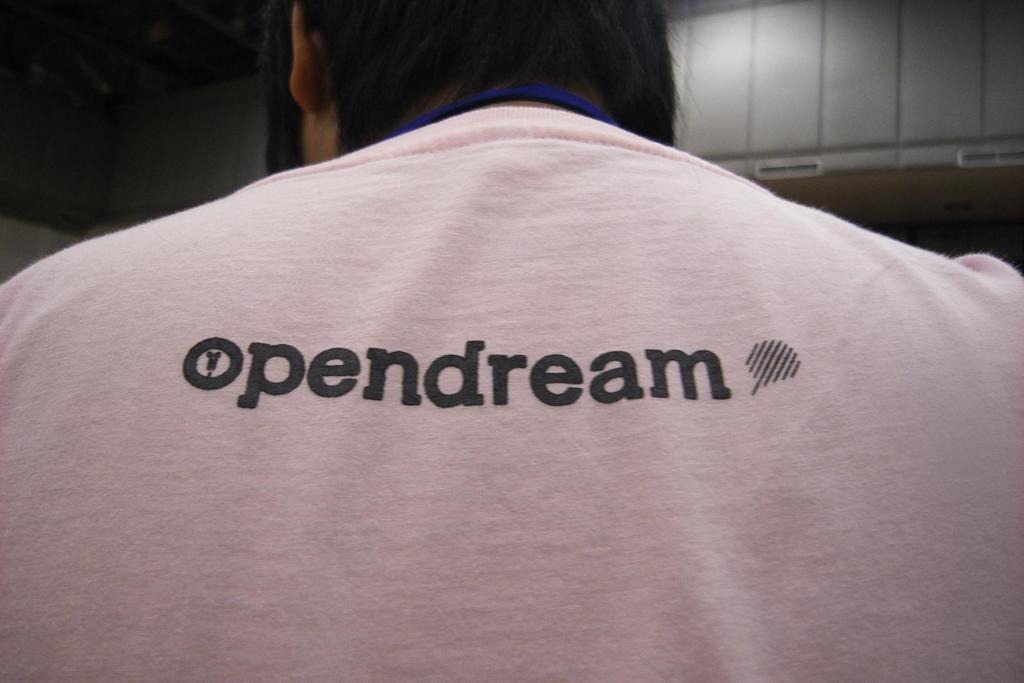What is the person in the picture wearing? The person in the picture is wearing a t-shirt. What is written on the back of the t-shirt? The words "open dream" are written on the back of the t-shirt. What can be seen in front of the person? There is a white color cupboard in front of the person. How many pets can be seen in the picture? There are no pets visible in the picture. What type of earthquake is happening in the background of the image? There is no earthquake present in the image; it is a still picture of a person wearing a t-shirt and a white color cupboard in front of them. 